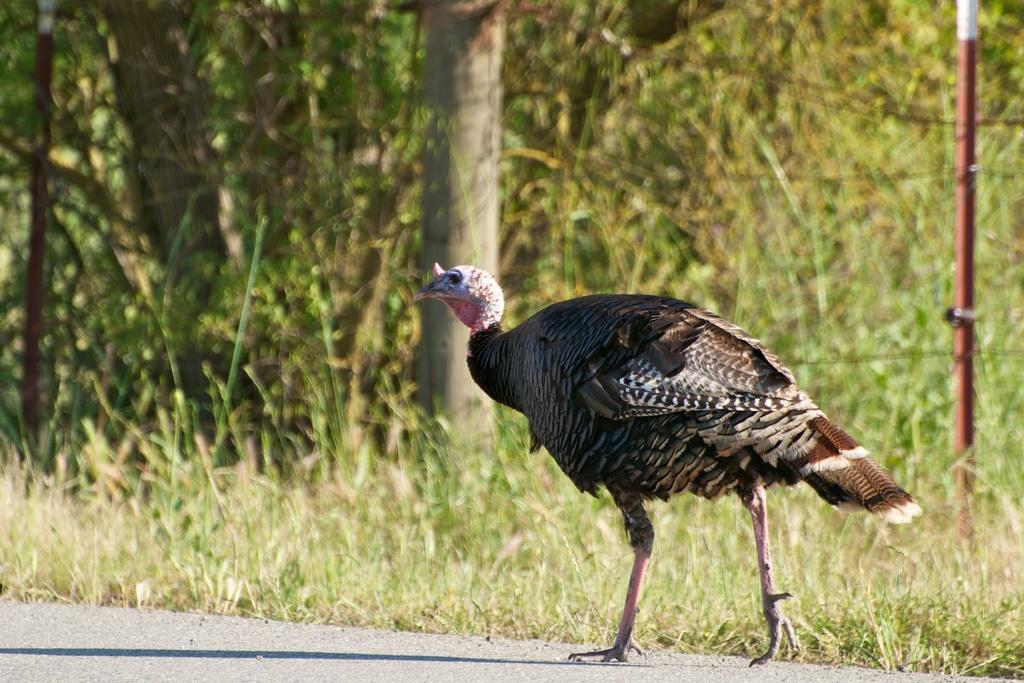What type of animal can be seen in the image? There is a bird in the image. Where is the bird located in the image? The bird is on the road surface. What type of surface is visible in the background of the image? There is a grass surface in the image. What type of vegetation is present in the image? There are trees in the image. What structures can be seen on either side of the road? There are two poles on either side of the road. What type of voice does the bird have in the image? The image does not provide any information about the bird's voice. Is there a lawyer present in the image? There is no mention of a lawyer in the image. 